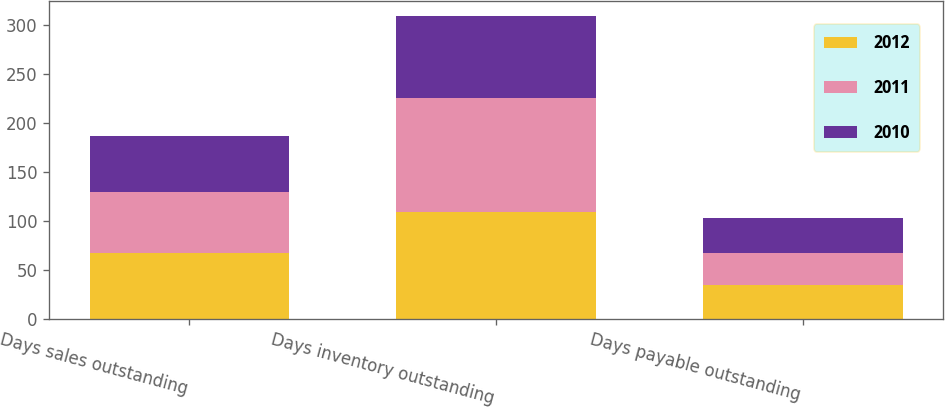Convert chart to OTSL. <chart><loc_0><loc_0><loc_500><loc_500><stacked_bar_chart><ecel><fcel>Days sales outstanding<fcel>Days inventory outstanding<fcel>Days payable outstanding<nl><fcel>2012<fcel>67<fcel>109<fcel>34<nl><fcel>2011<fcel>62<fcel>116<fcel>33<nl><fcel>2010<fcel>58<fcel>84<fcel>36<nl></chart> 